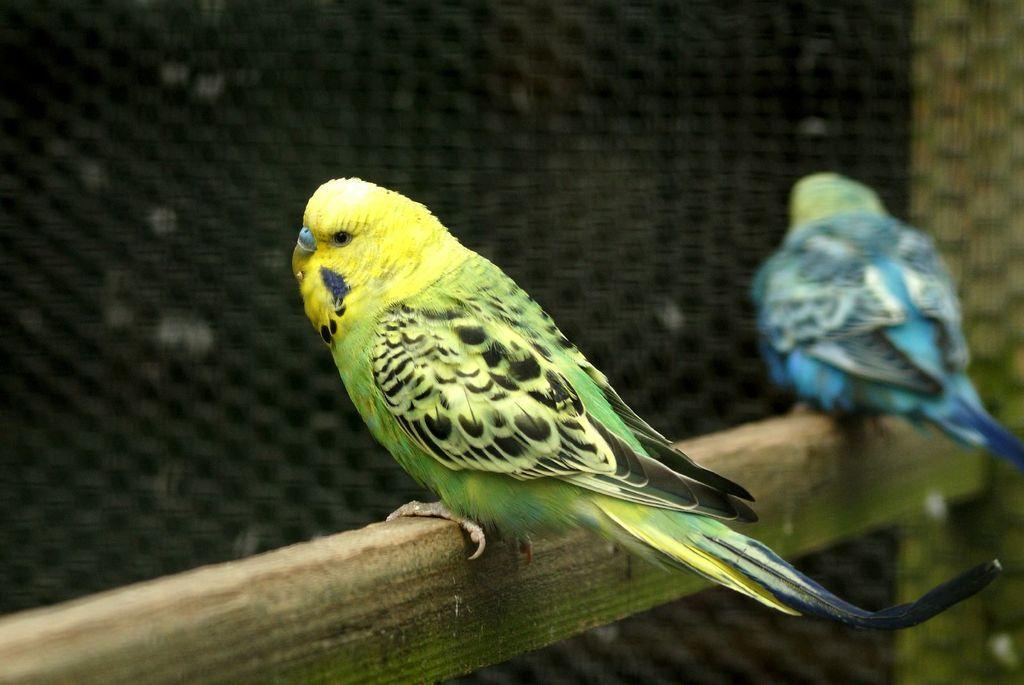Describe this image in one or two sentences. In this image I can see two birds and colour of these birds are blue, green and black. I can also see this image is little bit blurry from background. 